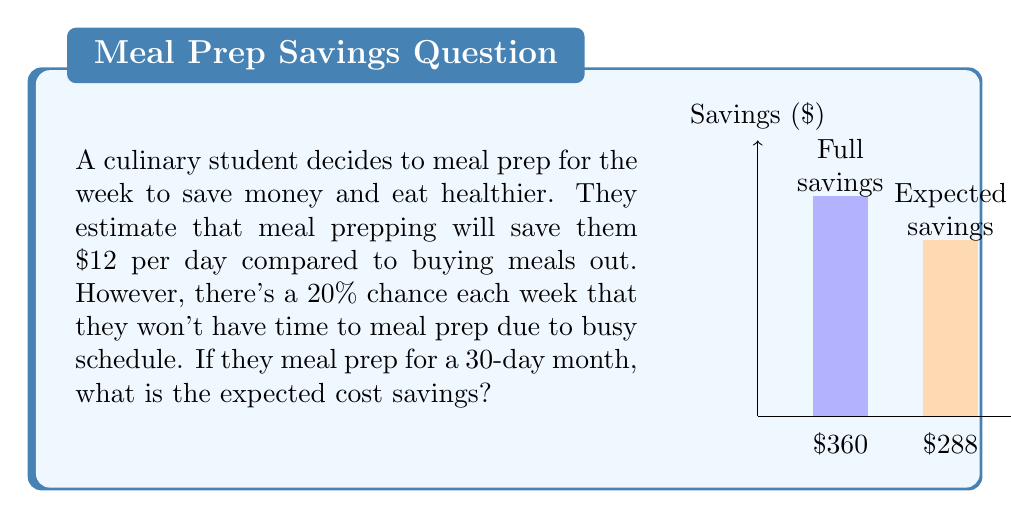Solve this math problem. Let's approach this step-by-step:

1) First, we calculate the maximum possible savings if the student meal preps every day:
   $$ \text{Maximum savings} = 30 \text{ days} \times \$12 \text{ per day} = \$360 $$

2) Now, we need to consider the probability of meal prepping. There's an 80% chance (100% - 20%) of meal prepping each week.

3) To calculate the expected savings, we multiply the maximum savings by the probability of meal prepping:
   $$ \text{Expected savings} = \$360 \times 0.80 = \$288 $$

4) We can also think about this in terms of expected value:
   $$ E(\text{savings}) = 0.80 \times \$360 + 0.20 \times \$0 = \$288 $$

   This is because there's an 80% chance of saving $360 and a 20% chance of saving $0 (when they don't meal prep).

5) Therefore, the expected cost savings for the month is $288.
Answer: $288 